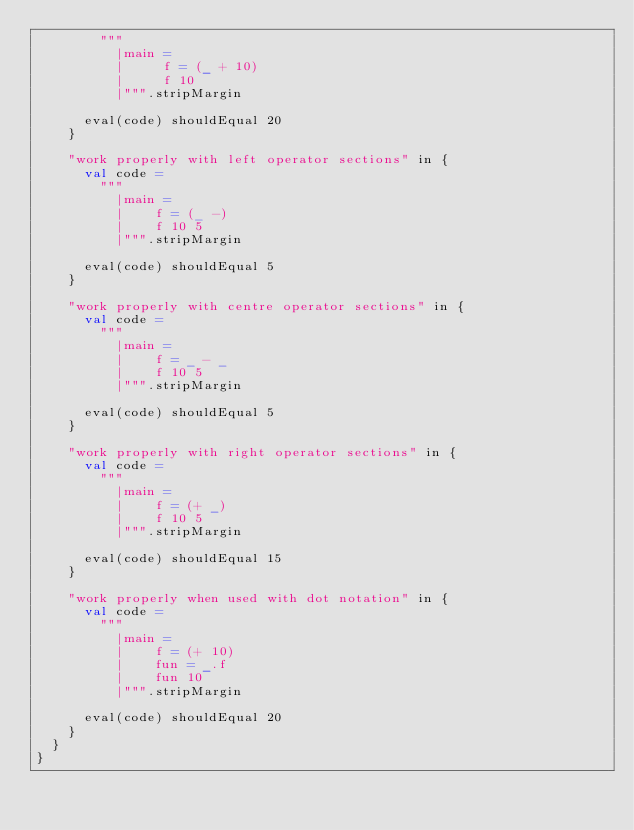<code> <loc_0><loc_0><loc_500><loc_500><_Scala_>        """
          |main =
          |     f = (_ + 10)
          |     f 10
          |""".stripMargin

      eval(code) shouldEqual 20
    }

    "work properly with left operator sections" in {
      val code =
        """
          |main =
          |    f = (_ -)
          |    f 10 5
          |""".stripMargin

      eval(code) shouldEqual 5
    }

    "work properly with centre operator sections" in {
      val code =
        """
          |main =
          |    f = _ - _
          |    f 10 5
          |""".stripMargin

      eval(code) shouldEqual 5
    }

    "work properly with right operator sections" in {
      val code =
        """
          |main =
          |    f = (+ _)
          |    f 10 5
          |""".stripMargin

      eval(code) shouldEqual 15
    }

    "work properly when used with dot notation" in {
      val code =
        """
          |main =
          |    f = (+ 10)
          |    fun = _.f
          |    fun 10
          |""".stripMargin

      eval(code) shouldEqual 20
    }
  }
}
</code> 